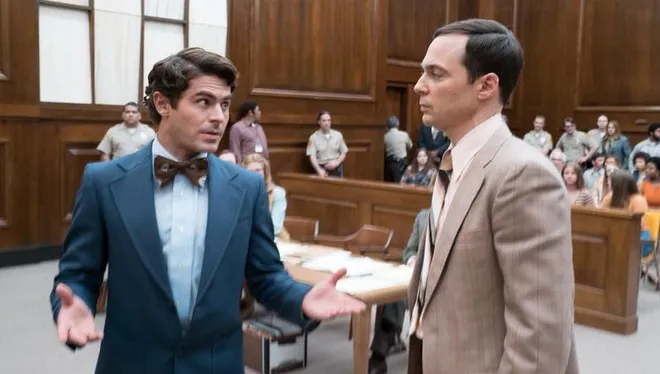Explain the visual content of the image in great detail. This image depicts a scene that appears to be set in a courtroom. The main focus is on two male characters who are positioned at the center of the image, one wearing a blue suit with a bowtie and the other in a beige suit. The man in the blue suit appears animated and engaged in making a point, with his hands gesturing expressively, reflecting the intensity of the situation. The man in the beige suit is paying close attention to his counterpart, with a serious expression on his face that suggests he is intently following the discussion. In the background, there are others seated, observing the interaction, contributing to the impression of a formal legal proceeding. The environment is constructed to depict the gravity associated with court settings, and individuals in this image portray their roles with dramatic flair. 